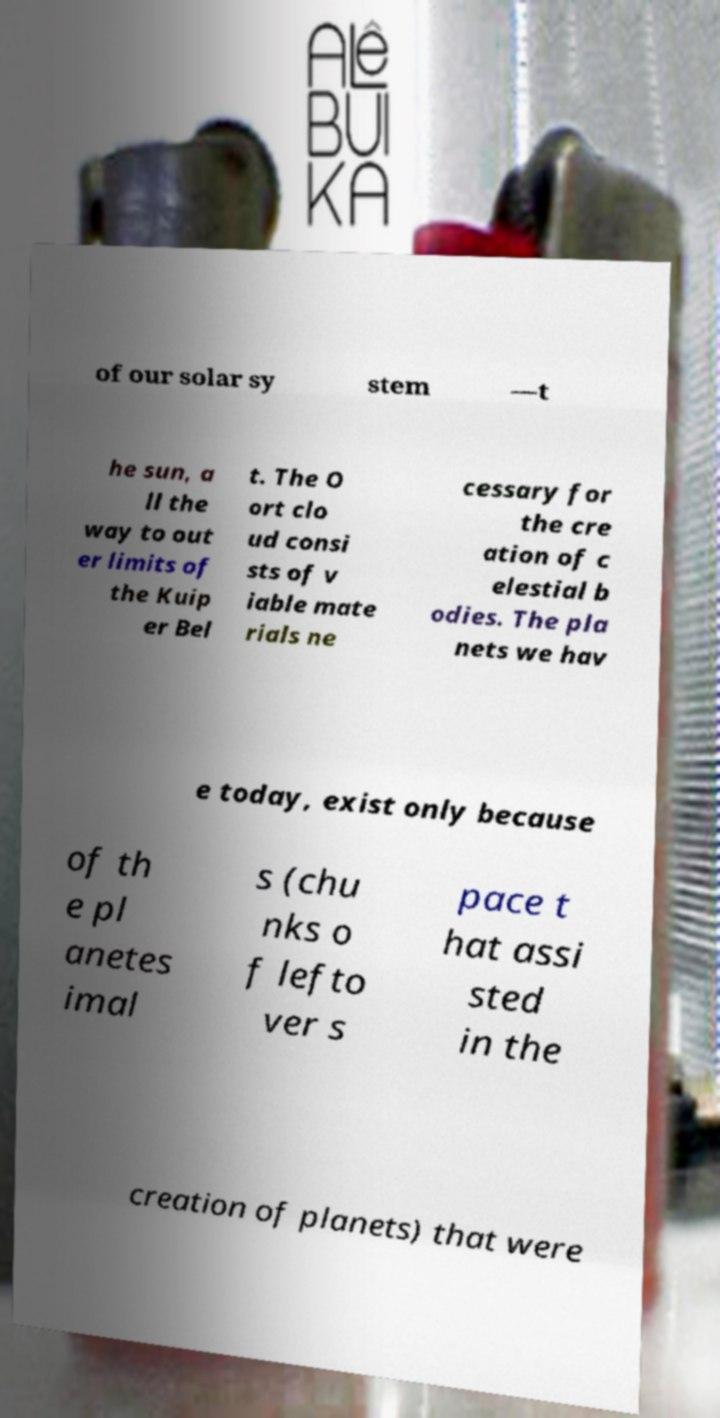What messages or text are displayed in this image? I need them in a readable, typed format. of our solar sy stem —t he sun, a ll the way to out er limits of the Kuip er Bel t. The O ort clo ud consi sts of v iable mate rials ne cessary for the cre ation of c elestial b odies. The pla nets we hav e today, exist only because of th e pl anetes imal s (chu nks o f lefto ver s pace t hat assi sted in the creation of planets) that were 